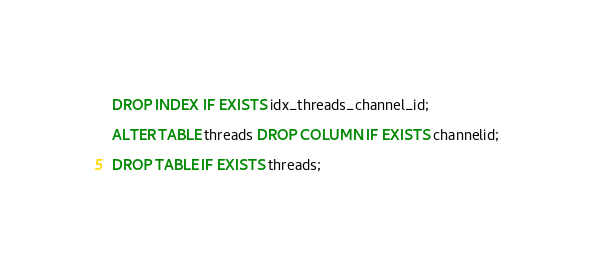<code> <loc_0><loc_0><loc_500><loc_500><_SQL_>DROP INDEX IF EXISTS idx_threads_channel_id;

ALTER TABLE threads DROP COLUMN IF EXISTS channelid;

DROP TABLE IF EXISTS threads;
</code> 